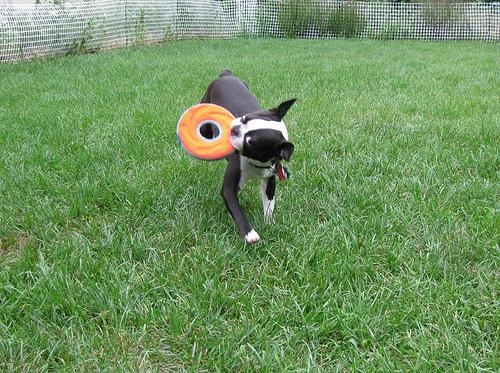Question: why is it moving?
Choices:
A. Driving.
B. Playing.
C. Being pulled.
D. Being pushed.
Answer with the letter. Answer: B Question: where is this scene?
Choices:
A. A parade.
B. A ski resort.
C. In the grass.
D. A broadway play.
Answer with the letter. Answer: C Question: who is present?
Choices:
A. A man.
B. A woman.
C. Nobody.
D. A dog.
Answer with the letter. Answer: C Question: how is the photo?
Choices:
A. Sharp.
B. Clear.
C. Blurry.
D. Ripped.
Answer with the letter. Answer: B 